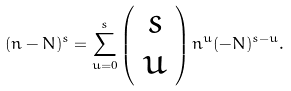Convert formula to latex. <formula><loc_0><loc_0><loc_500><loc_500>( n - N ) ^ { s } = \sum _ { u = 0 } ^ { s } \left ( \begin{array} { c } s \\ u \end{array} \right ) n ^ { u } ( - N ) ^ { s - u } .</formula> 